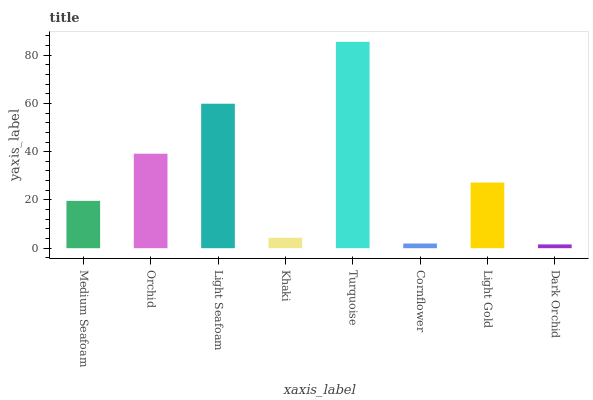Is Dark Orchid the minimum?
Answer yes or no. Yes. Is Turquoise the maximum?
Answer yes or no. Yes. Is Orchid the minimum?
Answer yes or no. No. Is Orchid the maximum?
Answer yes or no. No. Is Orchid greater than Medium Seafoam?
Answer yes or no. Yes. Is Medium Seafoam less than Orchid?
Answer yes or no. Yes. Is Medium Seafoam greater than Orchid?
Answer yes or no. No. Is Orchid less than Medium Seafoam?
Answer yes or no. No. Is Light Gold the high median?
Answer yes or no. Yes. Is Medium Seafoam the low median?
Answer yes or no. Yes. Is Dark Orchid the high median?
Answer yes or no. No. Is Khaki the low median?
Answer yes or no. No. 